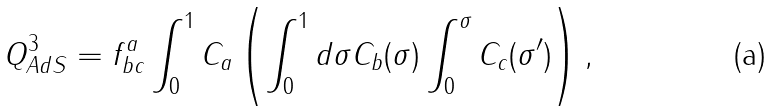<formula> <loc_0><loc_0><loc_500><loc_500>Q ^ { 3 } _ { A d S } = f ^ { a } _ { b c } \int _ { 0 } ^ { 1 } { C _ { a } } \left ( \int _ { 0 } ^ { 1 } { d \sigma C _ { b } ( \sigma ) \int _ { 0 } ^ { \sigma } C _ { c } ( \sigma ^ { \prime } ) } \right ) ,</formula> 